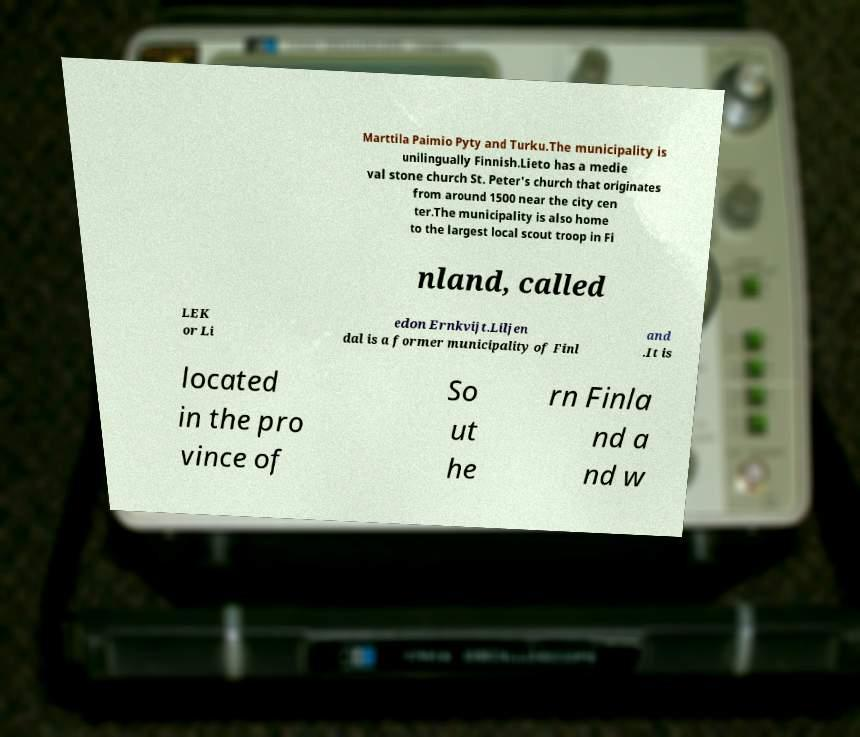Could you assist in decoding the text presented in this image and type it out clearly? Marttila Paimio Pyty and Turku.The municipality is unilingually Finnish.Lieto has a medie val stone church St. Peter's church that originates from around 1500 near the city cen ter.The municipality is also home to the largest local scout troop in Fi nland, called LEK or Li edon Ernkvijt.Liljen dal is a former municipality of Finl and .It is located in the pro vince of So ut he rn Finla nd a nd w 